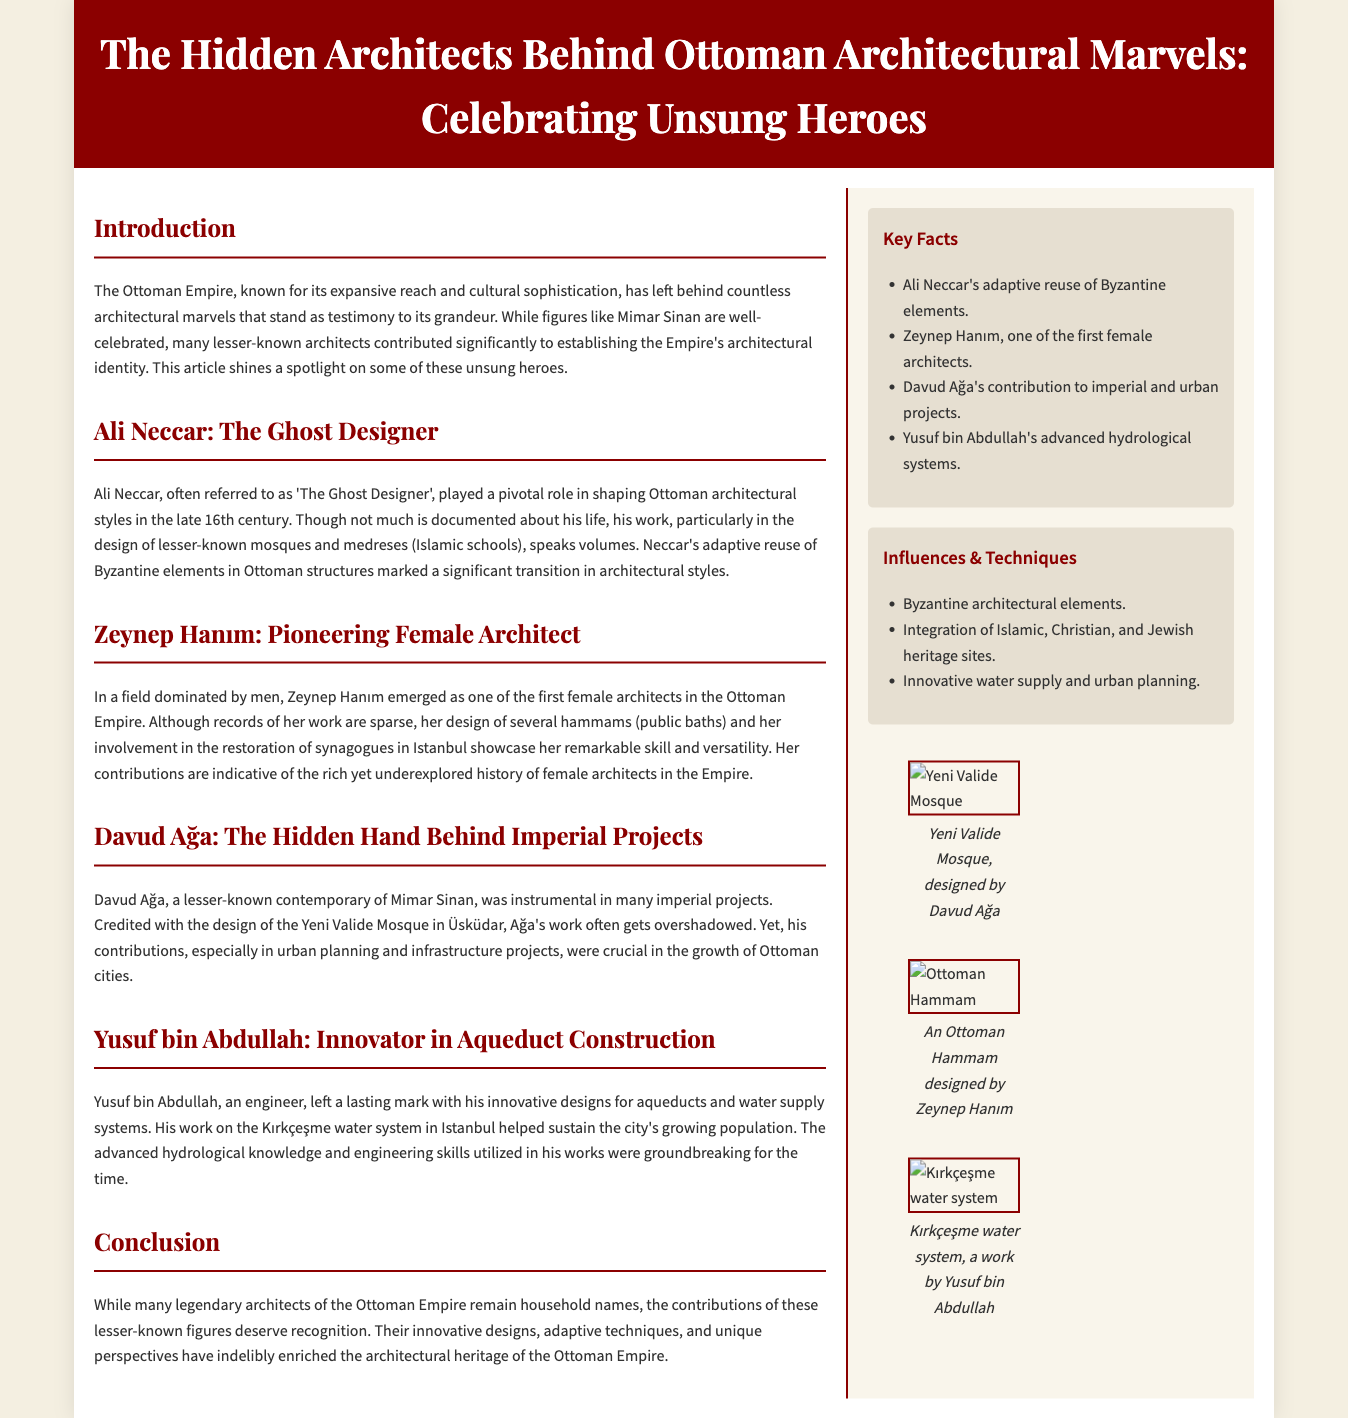What is the title of the article? The title is prominently displayed at the top of the document, highlighting the focus on Ottoman architectural figures.
Answer: The Hidden Architects Behind Ottoman Architectural Marvels: Celebrating Unsung Heroes Who is referred to as 'The Ghost Designer'? This name is attributed to Ali Neccar, mentioned in the section about lesser-known architects.
Answer: Ali Neccar What architectural elements did Ali Neccar reuse? The document specifies that he reused elements from a particular historical architecture.
Answer: Byzantine elements Which female architect is mentioned in the document? The document highlights a pioneering female architect who made significant contributions during the Ottoman Empire.
Answer: Zeynep Hanım What was Davud Ağa credited with designing? The document lists a specific mosque that Davud Ağa designed, showcasing his contributions.
Answer: Yeni Valide Mosque What innovative system did Yusuf bin Abdullah work on? This question refers to the notable contributions made by Yusuf bin Abdullah as mentioned in the context of urban infrastructure.
Answer: Aqueduct construction How many sidebar sections are present in the document? The sidebar consists of additional information sections that complement the main content.
Answer: Two What role did Zeynep Hanım play in the Ottoman Empire's architecture? The context describes her involvement in the design of public facilities in a male-dominated field.
Answer: Pioneering Female Architect 